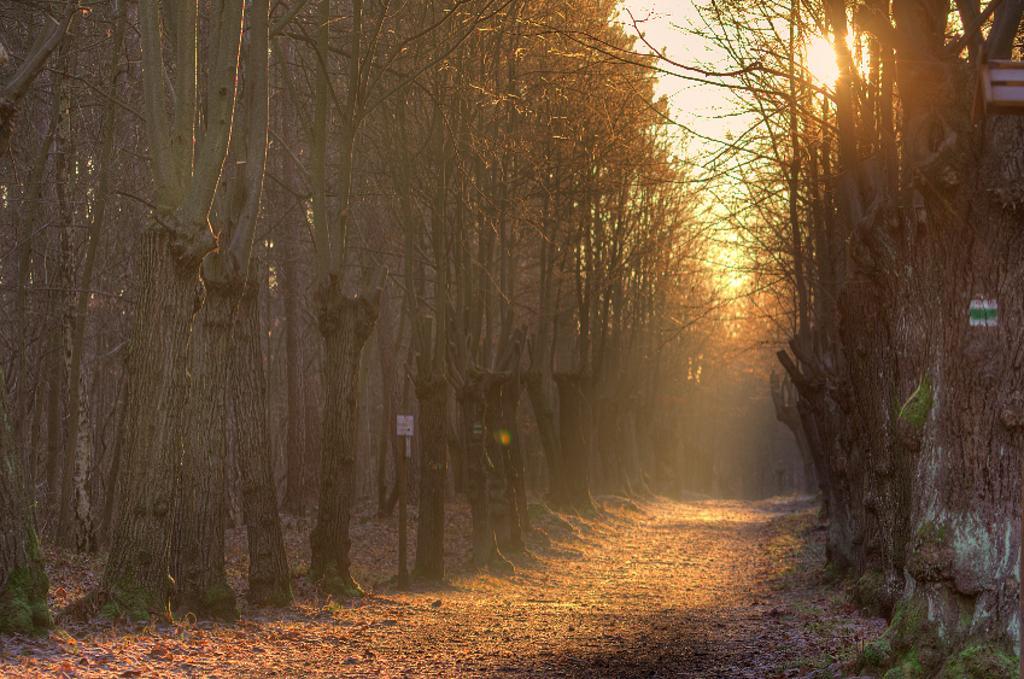Please provide a concise description of this image. In this image I see the trees and I see the path. In the background I see the sky and I see the sun over here. 